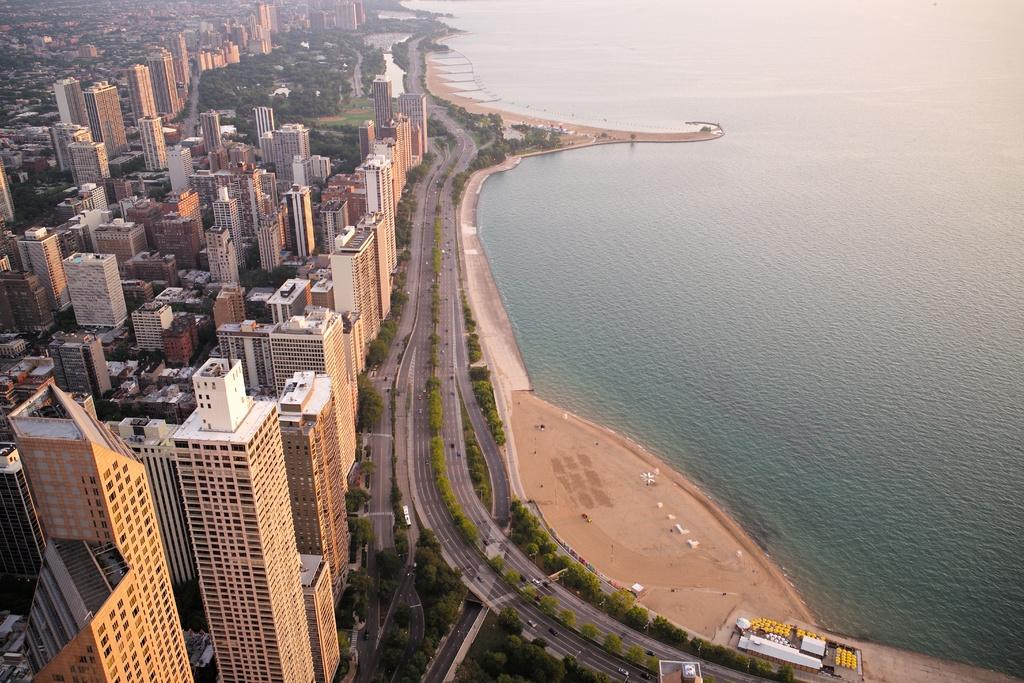What type of structures can be seen in the image? There are buildings in the image. What natural elements are present in the image? There are trees and grass in the image. What man-made elements can be seen in the image? There are roads in the image. What can be seen on the right side of the image? There is water visible on the right side of the image. What is moving along the roads in the image? There are vehicles traveling on the roads. What type of animal is sitting on the page in the image? There is no animal sitting on a page in the image; the image does not contain any pages or animals. How many grapes can be seen in the image? There are no grapes present in the image. 